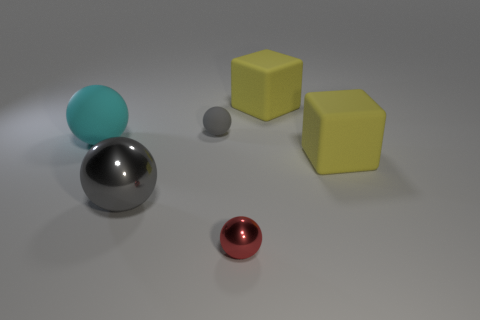Subtract all cyan blocks. How many gray spheres are left? 2 Subtract all gray shiny balls. How many balls are left? 3 Subtract all red balls. How many balls are left? 3 Subtract all blue spheres. Subtract all purple cylinders. How many spheres are left? 4 Add 1 large yellow blocks. How many objects exist? 7 Subtract all spheres. How many objects are left? 2 Subtract 0 purple cubes. How many objects are left? 6 Subtract all small red objects. Subtract all big purple shiny cylinders. How many objects are left? 5 Add 5 large rubber balls. How many large rubber balls are left? 6 Add 3 big gray shiny balls. How many big gray shiny balls exist? 4 